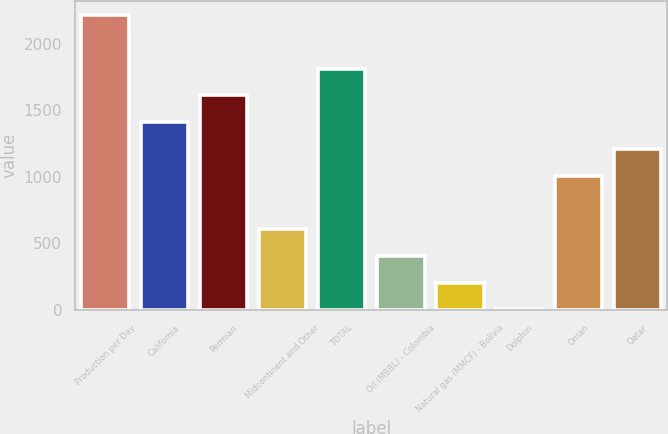Convert chart. <chart><loc_0><loc_0><loc_500><loc_500><bar_chart><fcel>Production per Day<fcel>California<fcel>Permian<fcel>Midcontinent and Other<fcel>TOTAL<fcel>Oil (MBBL) - Colombia<fcel>Natural gas (MMCF) - Bolivia<fcel>Dolphin<fcel>Oman<fcel>Qatar<nl><fcel>2213.7<fcel>1410.9<fcel>1611.6<fcel>608.1<fcel>1812.3<fcel>407.4<fcel>206.7<fcel>6<fcel>1009.5<fcel>1210.2<nl></chart> 